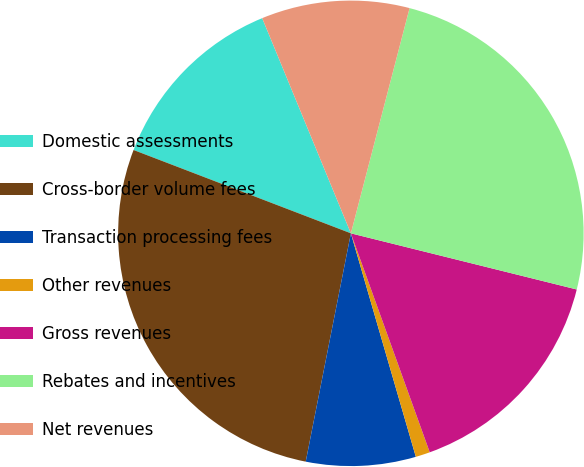Convert chart. <chart><loc_0><loc_0><loc_500><loc_500><pie_chart><fcel>Domestic assessments<fcel>Cross-border volume fees<fcel>Transaction processing fees<fcel>Other revenues<fcel>Gross revenues<fcel>Rebates and incentives<fcel>Net revenues<nl><fcel>12.95%<fcel>27.72%<fcel>7.61%<fcel>1.0%<fcel>15.62%<fcel>24.82%<fcel>10.28%<nl></chart> 